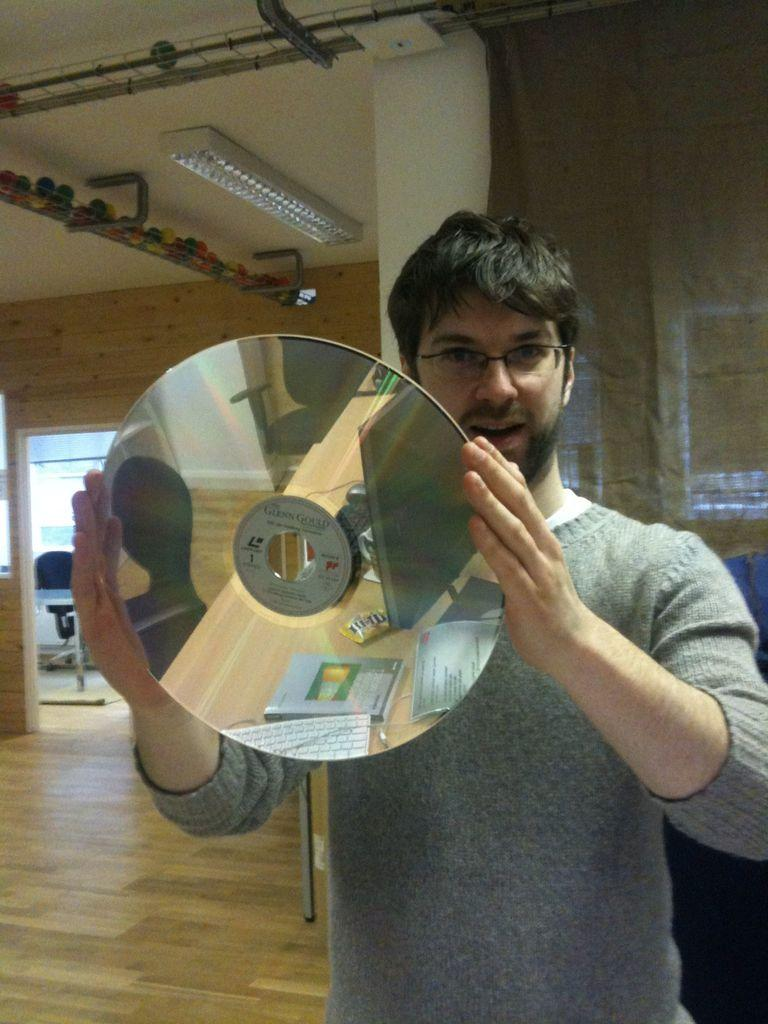What is the person in the image holding? The person is holding a disc in the image. What does the disc reflect? The disc reflects a monitor, books, and other objects. What can be seen on the ceiling in the image? There are lights on the ceiling in the image. What part of a building or space does the image depict? The image depicts an entrance. How many toads can be seen hopping around in the image? There are no toads present in the image. What type of print is visible on the disc in the image? There is no print visible on the disc in the image; it reflects various objects, including a monitor and books. 